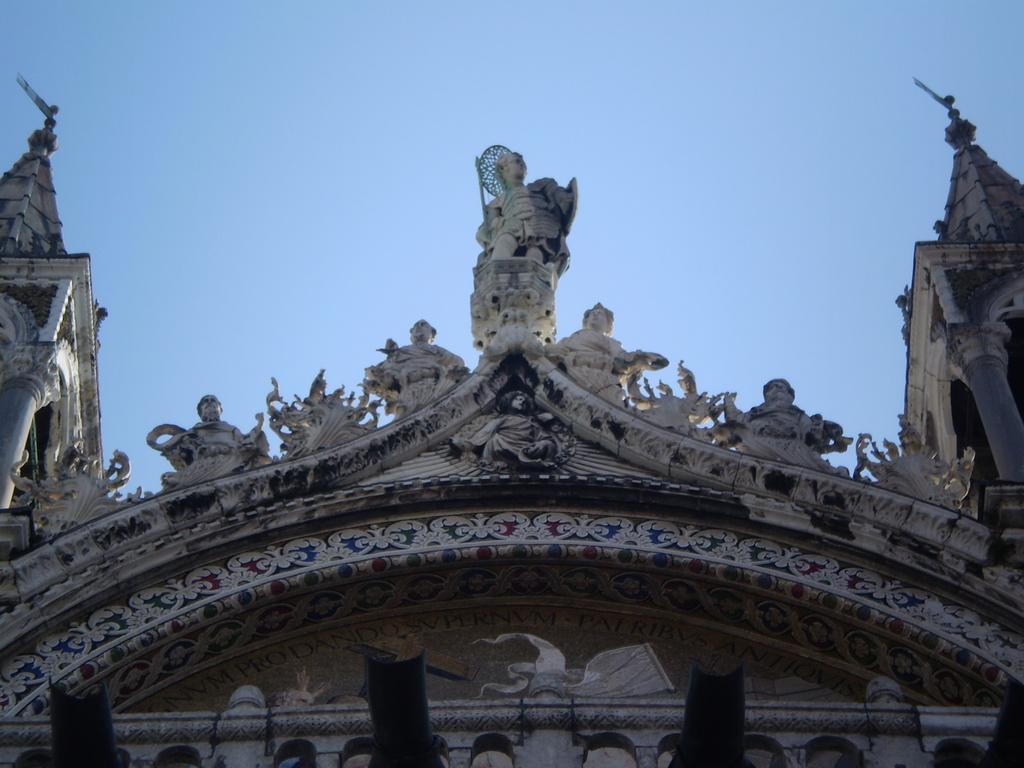Describe this image in one or two sentences. This picture consists of st mark's basilica in the image. 